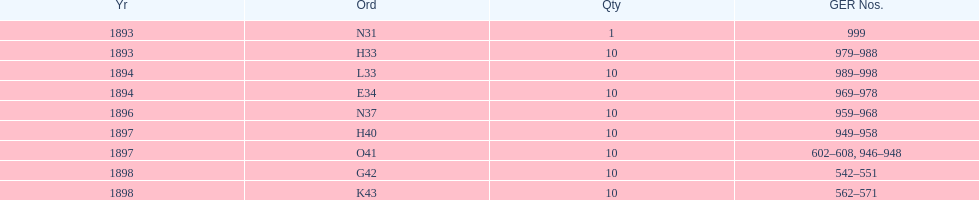Was the quantity higher in 1894 or 1893? 1894. 